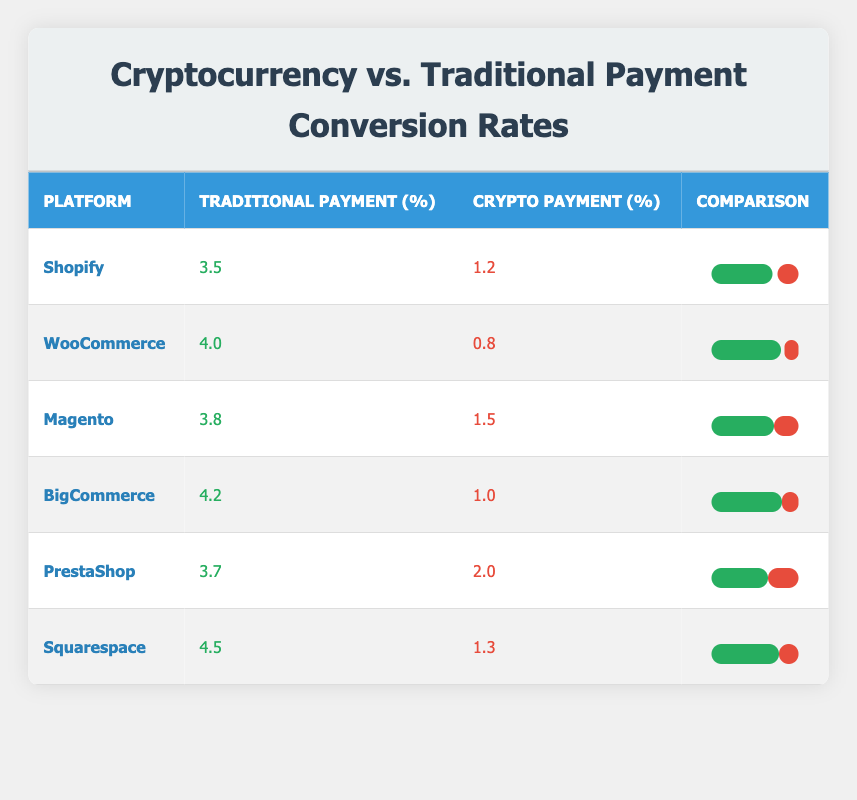What is the traditional payment conversion rate for BigCommerce? The table shows that the traditional payment conversion rate for BigCommerce is listed directly in the "Traditional Payment (%)" column, which indicates a rate of 4.2.
Answer: 4.2 Which platform has the highest crypto payment conversion rate? By comparing the values in the "Crypto Payment (%)" column, it's observed that PrestaShop has the highest value at 2.0, which is more than the other platforms.
Answer: PrestaShop What is the difference between the traditional payment and crypto payment conversion rates for Shopify? For Shopify, the traditional payment conversion rate is 3.5, and the crypto payment conversion rate is 1.2. The difference is calculated as 3.5 - 1.2 = 2.3.
Answer: 2.3 Is it true that traditional payment conversion rates are higher than crypto payment rates for all platforms? Reviewing the conversion rates from each platform shows that the traditional payment conversion rates exceed the crypto rates for all six platforms. Therefore, the statement is true.
Answer: Yes What is the average crypto payment conversion rate across all platforms? To find the average, sum all crypto payment rates: 1.2 + 0.8 + 1.5 + 1.0 + 2.0 + 1.3 = 8.0, and divide by the number of platforms (6): 8.0 / 6 = 1.33.
Answer: 1.33 What percentage of the traditional payment conversion rate does the crypto payment conversion rate represent for WooCommerce? For WooCommerce, the traditional payment conversion rate is 4.0, and the crypto rate is 0.8. The percentage is calculated by (0.8 / 4.0) * 100 = 20%.
Answer: 20% Which platform has the least traditional payment conversion rate? The platforms are compared based on the values in the "Traditional Payment (%)" column, and WooCommerce has the least rate at 4.0, as it is the smallest among the listed rates.
Answer: WooCommerce Calculate the total conversion rates (traditional + crypto) for Magento. The traditional rate for Magento is 3.8 and the crypto rate is 1.5. Adding the two gives 3.8 + 1.5 = 5.3.
Answer: 5.3 What is the conversion rate disparity in percentages between the highest and lowest traditional payment conversion rates? The highest traditional payment conversion rate is 4.5 (Squarespace) and the lowest is 4.0 (WooCommerce). The disparity is calculated as 4.5 - 4.0 = 0.5, which represents a percentage discrepancy of (0.5 / 4.0) * 100 = 12.5%.
Answer: 12.5% 